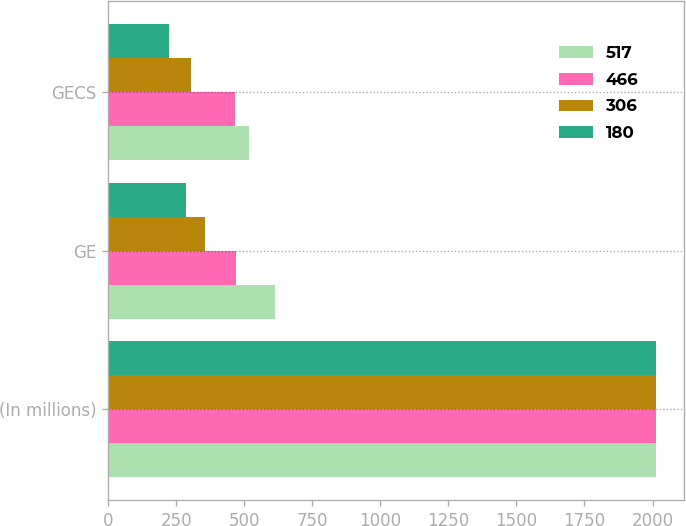Convert chart to OTSL. <chart><loc_0><loc_0><loc_500><loc_500><stacked_bar_chart><ecel><fcel>(In millions)<fcel>GE<fcel>GECS<nl><fcel>517<fcel>2011<fcel>613<fcel>517<nl><fcel>466<fcel>2012<fcel>470<fcel>466<nl><fcel>306<fcel>2013<fcel>355<fcel>306<nl><fcel>180<fcel>2014<fcel>286<fcel>223<nl></chart> 